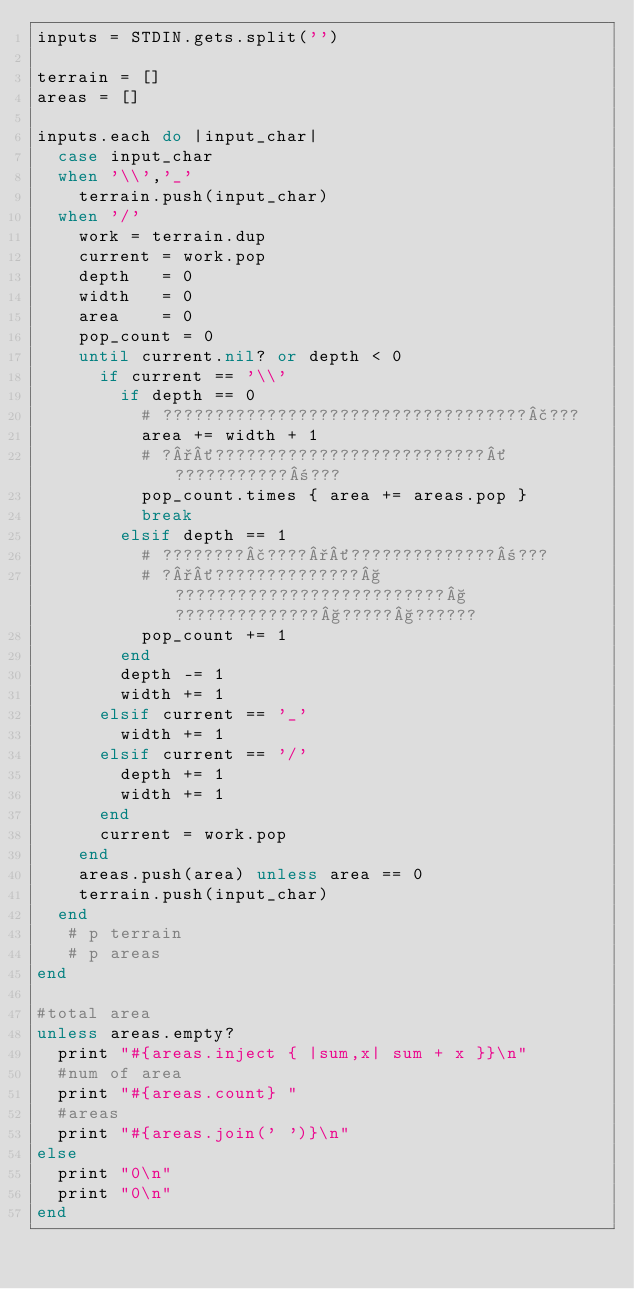Convert code to text. <code><loc_0><loc_0><loc_500><loc_500><_Ruby_>inputs = STDIN.gets.split('')

terrain = []
areas = []

inputs.each do |input_char|
  case input_char
  when '\\','_'
    terrain.push(input_char)
  when '/'
    work = terrain.dup
    current = work.pop
    depth   = 0
    width   = 0
    area    = 0
    pop_count = 0
    until current.nil? or depth < 0
      if current == '\\'
        if depth == 0
          # ???????????????????????????????????£???
          area += width + 1
          # ?°´??????????????????????????´???????????±???
          pop_count.times { area += areas.pop }
          break
        elsif depth == 1
          # ????????£????°´??????????????±???
          # ?°´??????????????§??????????????????????????§??????????????§?????§??????
          pop_count += 1
        end
        depth -= 1
        width += 1
      elsif current == '_'
        width += 1
      elsif current == '/'
        depth += 1
        width += 1
      end
      current = work.pop
    end
    areas.push(area) unless area == 0
    terrain.push(input_char)
  end
   # p terrain
   # p areas
end

#total area
unless areas.empty?
  print "#{areas.inject { |sum,x| sum + x }}\n"
  #num of area
  print "#{areas.count} "
  #areas
  print "#{areas.join(' ')}\n"
else
  print "0\n"
  print "0\n"
end</code> 